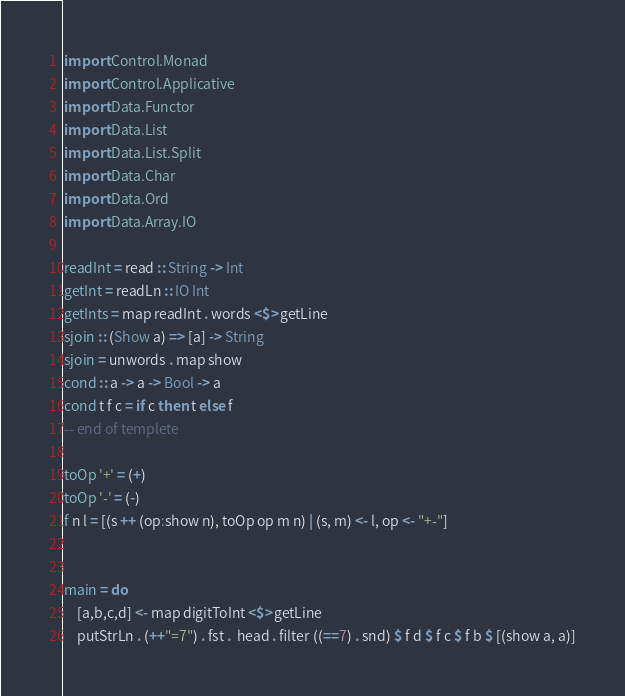<code> <loc_0><loc_0><loc_500><loc_500><_Haskell_>import Control.Monad
import Control.Applicative
import Data.Functor
import Data.List
import Data.List.Split
import Data.Char
import Data.Ord
import Data.Array.IO

readInt = read :: String -> Int
getInt = readLn :: IO Int
getInts = map readInt . words <$> getLine
sjoin :: (Show a) => [a] -> String
sjoin = unwords . map show
cond :: a -> a -> Bool -> a
cond t f c = if c then t else f
-- end of templete

toOp '+' = (+)
toOp '-' = (-)
f n l = [(s ++ (op:show n), toOp op m n) | (s, m) <- l, op <- "+-"]


main = do
    [a,b,c,d] <- map digitToInt <$> getLine
    putStrLn . (++"=7") . fst .  head . filter ((==7) . snd) $ f d $ f c $ f b $ [(show a, a)]</code> 